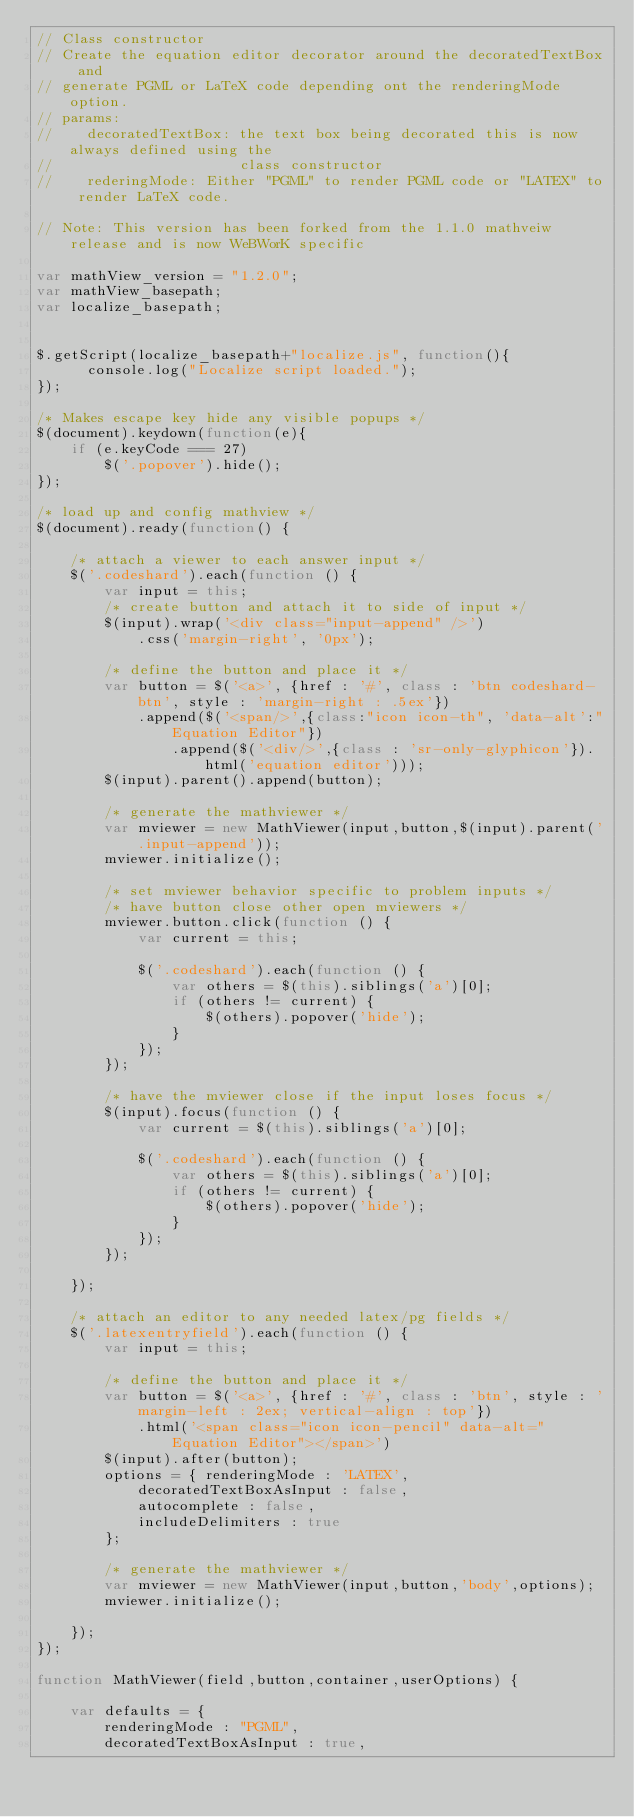Convert code to text. <code><loc_0><loc_0><loc_500><loc_500><_JavaScript_>// Class constructor
// Create the equation editor decorator around the decoratedTextBox and
// generate PGML or LaTeX code depending ont the renderingMode option.
// params:
//    decoratedTextBox: the text box being decorated this is now always defined using the
//                      class constructor
//    rederingMode: Either "PGML" to render PGML code or "LATEX" to render LaTeX code.

// Note: This version has been forked from the 1.1.0 mathveiw release and is now WeBWorK specific

var mathView_version = "1.2.0";
var mathView_basepath;
var localize_basepath;


$.getScript(localize_basepath+"localize.js", function(){
	  console.log("Localize script loaded.");
});

/* Makes escape key hide any visible popups */
$(document).keydown(function(e){
	if (e.keyCode === 27)
		$('.popover').hide();
});

/* load up and config mathview */
$(document).ready(function() {

	/* attach a viewer to each answer input */
	$('.codeshard').each(function () {
		var input = this;
		/* create button and attach it to side of input */
		$(input).wrap('<div class="input-append" />')
			.css('margin-right', '0px');

		/* define the button and place it */
		var button = $('<a>', {href : '#', class : 'btn codeshard-btn', style : 'margin-right : .5ex'})
			.append($('<span/>',{class:"icon icon-th", 'data-alt':"Equation Editor"})
				.append($('<div/>',{class : 'sr-only-glyphicon'}).html('equation editor')));
		$(input).parent().append(button);

		/* generate the mathviewer */
		var mviewer = new MathViewer(input,button,$(input).parent('.input-append'));
		mviewer.initialize();

		/* set mviewer behavior specific to problem inputs */
		/* have button close other open mviewers */
		mviewer.button.click(function () {
			var current = this;

			$('.codeshard').each(function () {
				var others = $(this).siblings('a')[0];
				if (others != current) {
					$(others).popover('hide');
				}
			});
		});

		/* have the mviewer close if the input loses focus */
		$(input).focus(function () {
			var current = $(this).siblings('a')[0];

			$('.codeshard').each(function () {
				var others = $(this).siblings('a')[0];
				if (others != current) {
					$(others).popover('hide');
				}
			});
		});

	});

	/* attach an editor to any needed latex/pg fields */
	$('.latexentryfield').each(function () {
		var input = this;

		/* define the button and place it */
		var button = $('<a>', {href : '#', class : 'btn', style : 'margin-left : 2ex; vertical-align : top'})
			.html('<span class="icon icon-pencil" data-alt="Equation Editor"></span>')
		$(input).after(button);
		options = { renderingMode : 'LATEX',
			decoratedTextBoxAsInput : false,
			autocomplete : false,
			includeDelimiters : true
		};

		/* generate the mathviewer */
		var mviewer = new MathViewer(input,button,'body',options);
		mviewer.initialize();

	});
});

function MathViewer(field,button,container,userOptions) {

	var defaults = {
		renderingMode : "PGML",
		decoratedTextBoxAsInput : true,</code> 